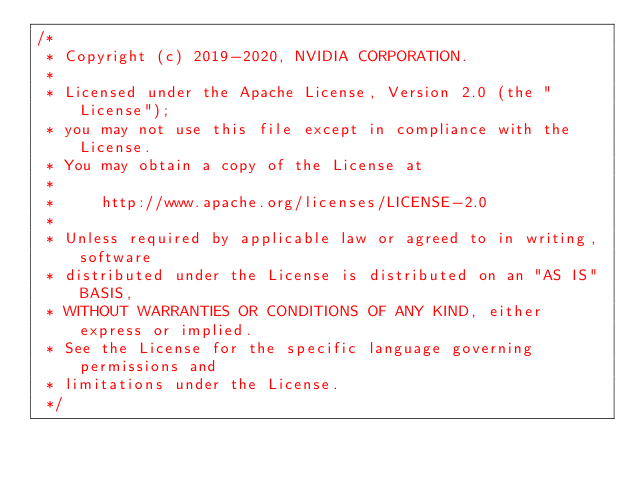<code> <loc_0><loc_0><loc_500><loc_500><_Cuda_>/*
 * Copyright (c) 2019-2020, NVIDIA CORPORATION.
 *
 * Licensed under the Apache License, Version 2.0 (the "License");
 * you may not use this file except in compliance with the License.
 * You may obtain a copy of the License at
 *
 *     http://www.apache.org/licenses/LICENSE-2.0
 *
 * Unless required by applicable law or agreed to in writing, software
 * distributed under the License is distributed on an "AS IS" BASIS,
 * WITHOUT WARRANTIES OR CONDITIONS OF ANY KIND, either express or implied.
 * See the License for the specific language governing permissions and
 * limitations under the License.
 */
</code> 